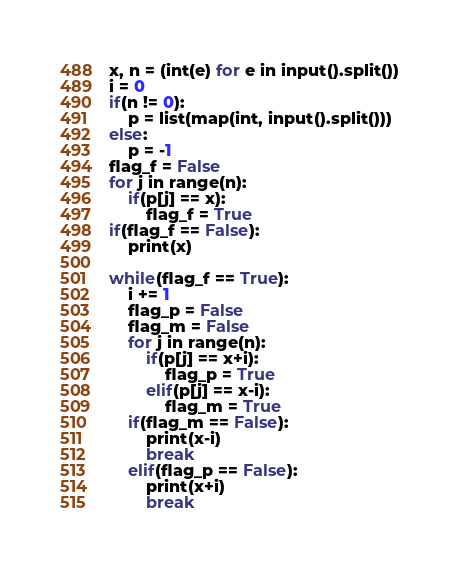Convert code to text. <code><loc_0><loc_0><loc_500><loc_500><_Python_>x, n = (int(e) for e in input().split())
i = 0
if(n != 0):
    p = list(map(int, input().split()))
else:
    p = -1
flag_f = False
for j in range(n):
    if(p[j] == x):
        flag_f = True
if(flag_f == False):
    print(x)

while(flag_f == True):
    i += 1
    flag_p = False
    flag_m = False
    for j in range(n):
        if(p[j] == x+i):
            flag_p = True
        elif(p[j] == x-i):
            flag_m = True
    if(flag_m == False):
        print(x-i)
        break
    elif(flag_p == False):
        print(x+i)
        break</code> 